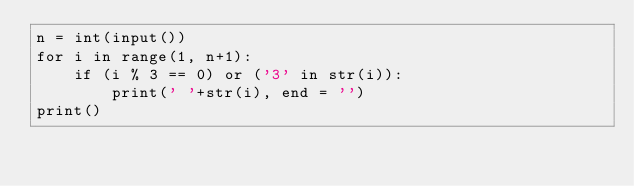Convert code to text. <code><loc_0><loc_0><loc_500><loc_500><_Python_>n = int(input())
for i in range(1, n+1):
	if (i % 3 == 0) or ('3' in str(i)):
		print(' '+str(i), end = '')
print()
</code> 